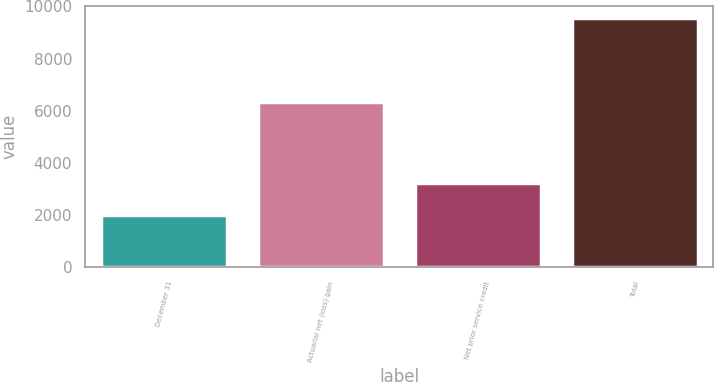<chart> <loc_0><loc_0><loc_500><loc_500><bar_chart><fcel>December 31<fcel>Actuarial net (loss) gain<fcel>Net prior service credit<fcel>Total<nl><fcel>2012<fcel>6320<fcel>3217<fcel>9537<nl></chart> 